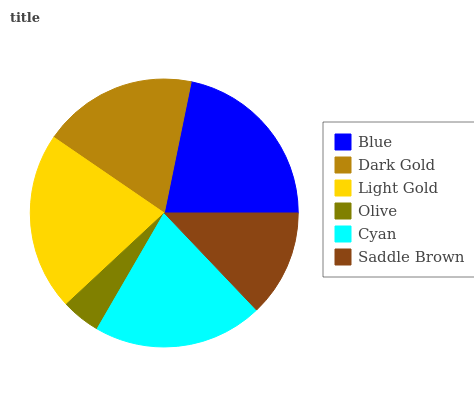Is Olive the minimum?
Answer yes or no. Yes. Is Blue the maximum?
Answer yes or no. Yes. Is Dark Gold the minimum?
Answer yes or no. No. Is Dark Gold the maximum?
Answer yes or no. No. Is Blue greater than Dark Gold?
Answer yes or no. Yes. Is Dark Gold less than Blue?
Answer yes or no. Yes. Is Dark Gold greater than Blue?
Answer yes or no. No. Is Blue less than Dark Gold?
Answer yes or no. No. Is Cyan the high median?
Answer yes or no. Yes. Is Dark Gold the low median?
Answer yes or no. Yes. Is Blue the high median?
Answer yes or no. No. Is Cyan the low median?
Answer yes or no. No. 